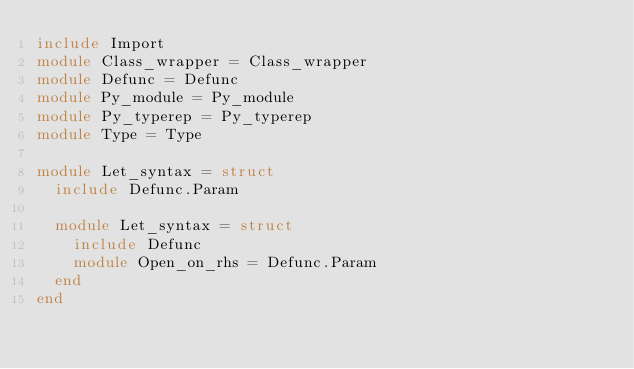<code> <loc_0><loc_0><loc_500><loc_500><_OCaml_>include Import
module Class_wrapper = Class_wrapper
module Defunc = Defunc
module Py_module = Py_module
module Py_typerep = Py_typerep
module Type = Type

module Let_syntax = struct
  include Defunc.Param

  module Let_syntax = struct
    include Defunc
    module Open_on_rhs = Defunc.Param
  end
end
</code> 